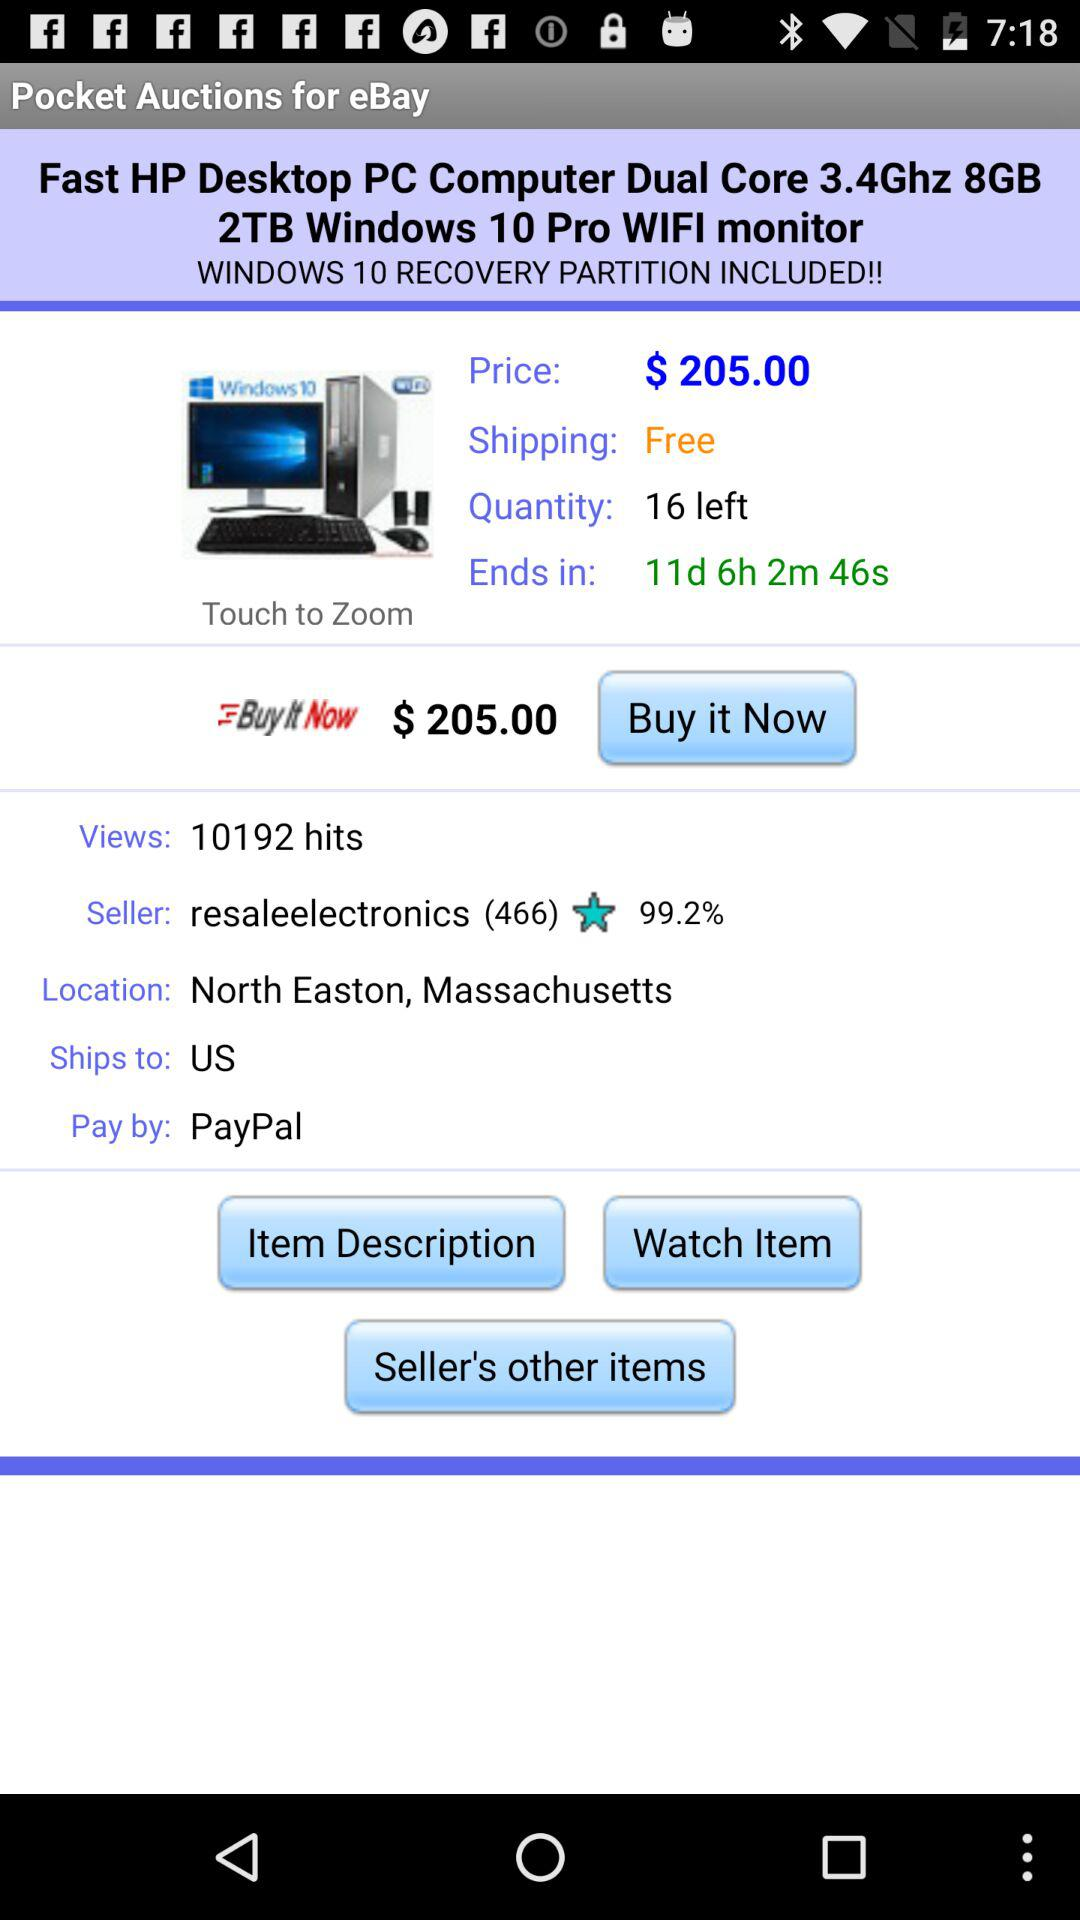What is the selected payment method? The selected payment method is "PayPal". 